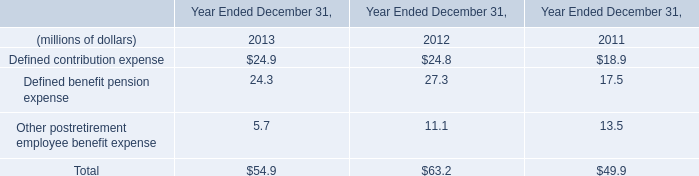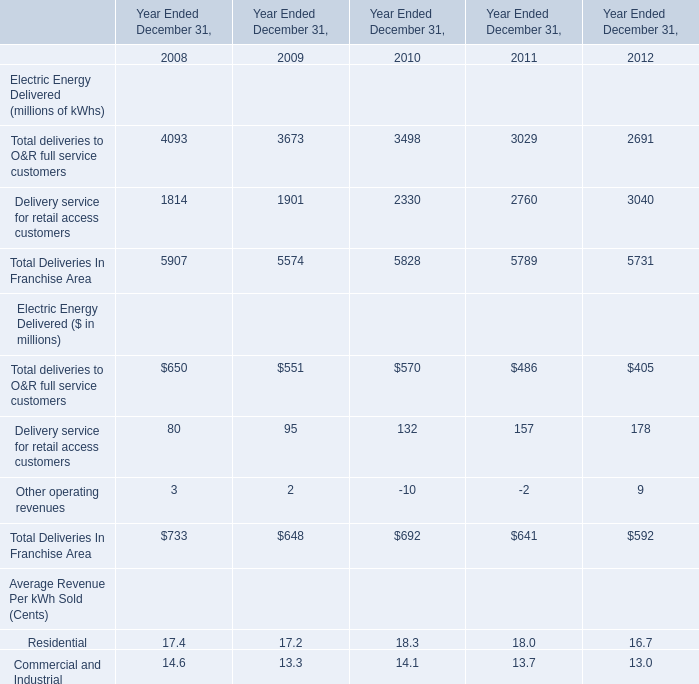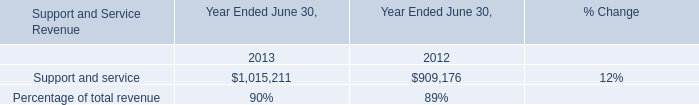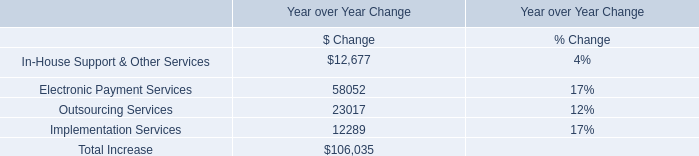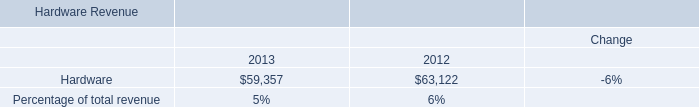What's the sum of the Defined benefit pension expense i n the years where Delivery service for retail access customers larger than 2700 ? (in million) 
Computations: (27.3 + 17.5)
Answer: 44.8. 